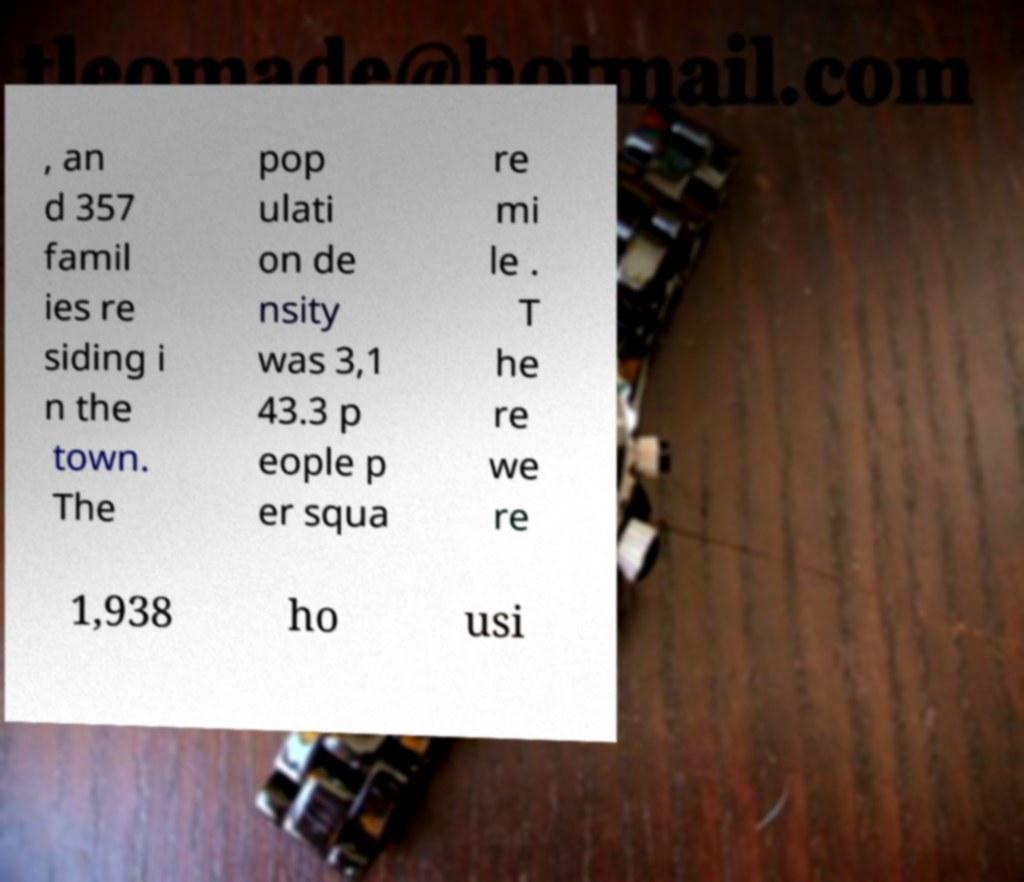I need the written content from this picture converted into text. Can you do that? , an d 357 famil ies re siding i n the town. The pop ulati on de nsity was 3,1 43.3 p eople p er squa re mi le . T he re we re 1,938 ho usi 